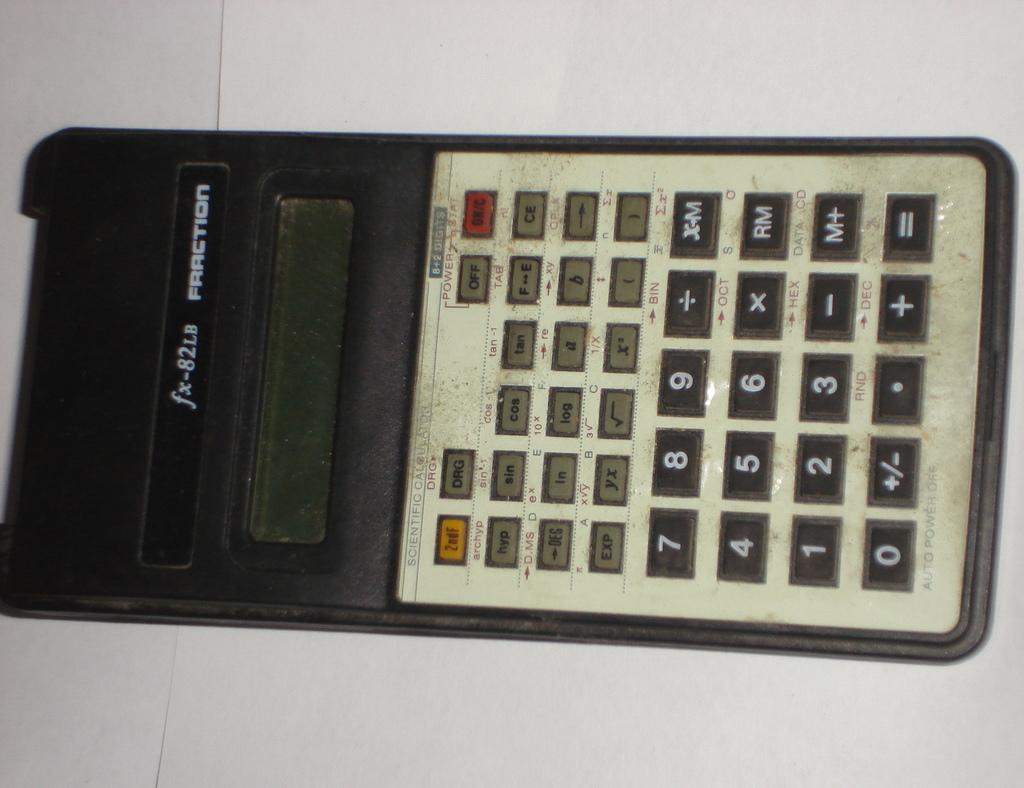<image>
Relay a brief, clear account of the picture shown. A fx-82LB fraction calculator lies on a table. 